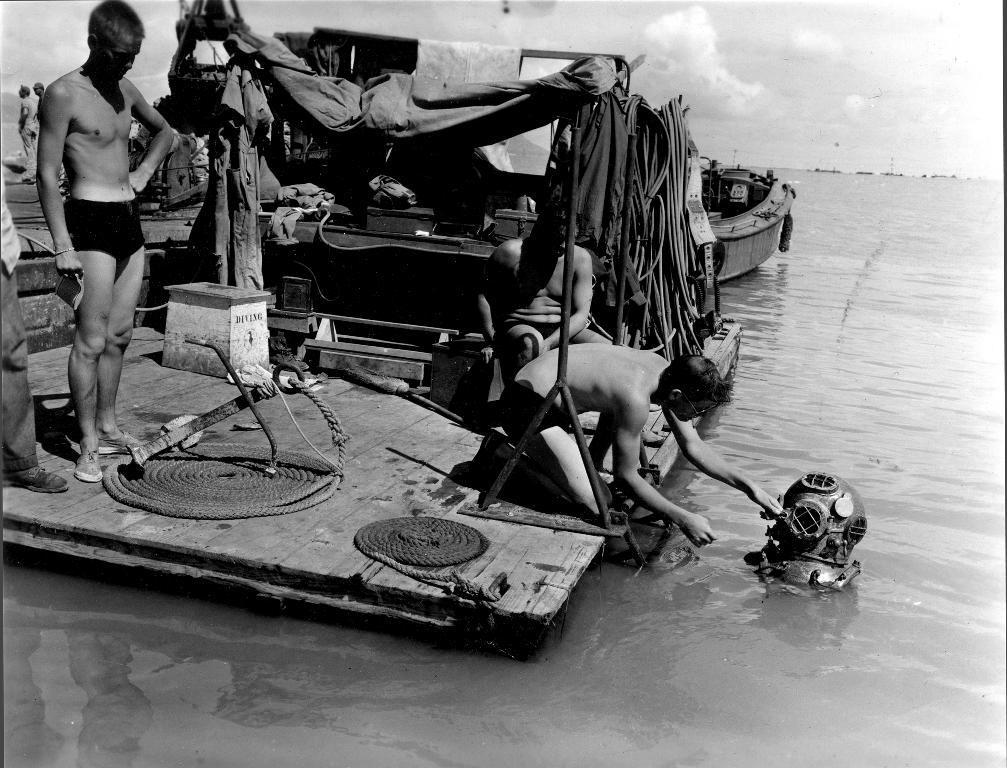Could you give a brief overview of what you see in this image? In the foreground of this black and white image, there are two men standing on the raft like structure and a man kneeling down and holding an object which is on the water surface and also a man sitting. We can also see ropes and clothes. Behind it, there is a boat, two men on the left and sky and the cloud at the top. 